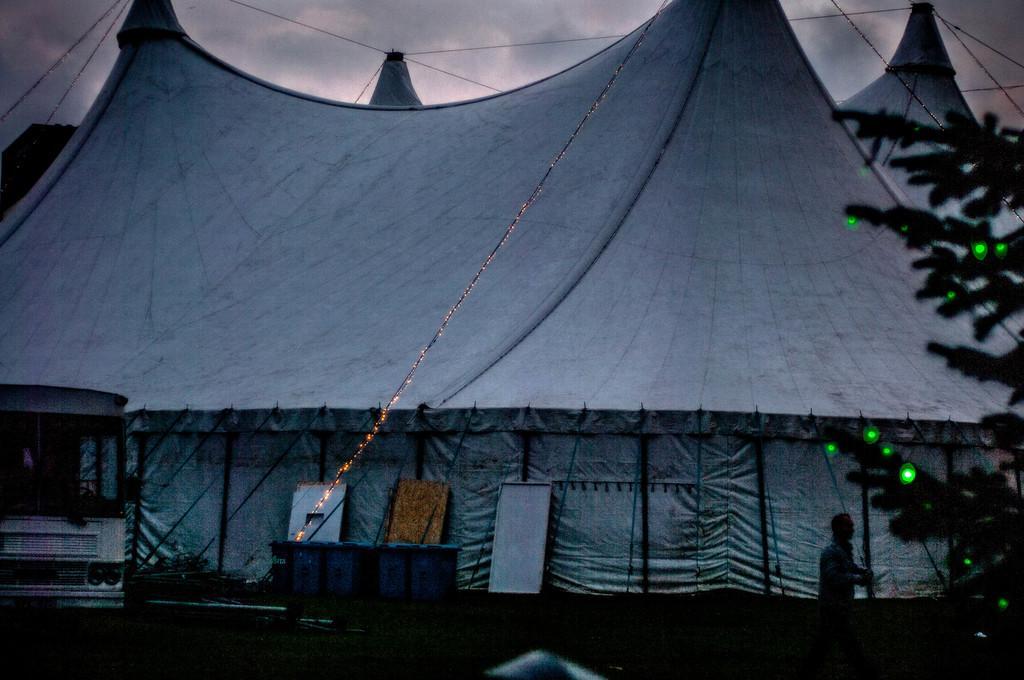Describe this image in one or two sentences. In this image there is a tent in the middle. There are lights to the ropes. On the right side there is a tree to which there are green lights. On the left side there is a bus on the road. In the middle there are dustbins. At the top there is the sky. 